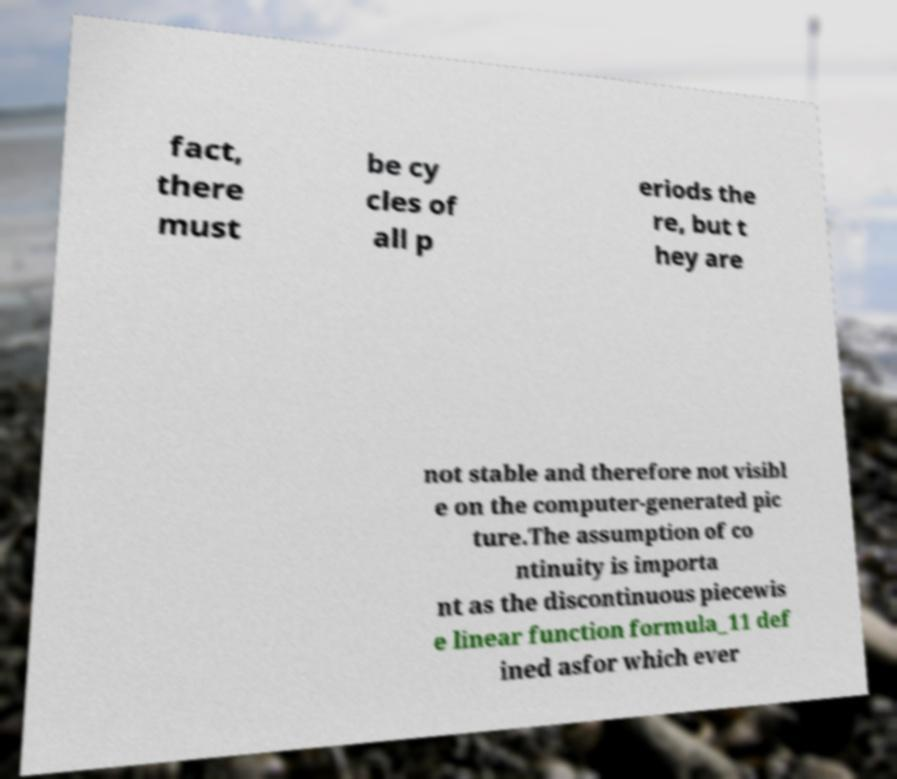Could you extract and type out the text from this image? fact, there must be cy cles of all p eriods the re, but t hey are not stable and therefore not visibl e on the computer-generated pic ture.The assumption of co ntinuity is importa nt as the discontinuous piecewis e linear function formula_11 def ined asfor which ever 